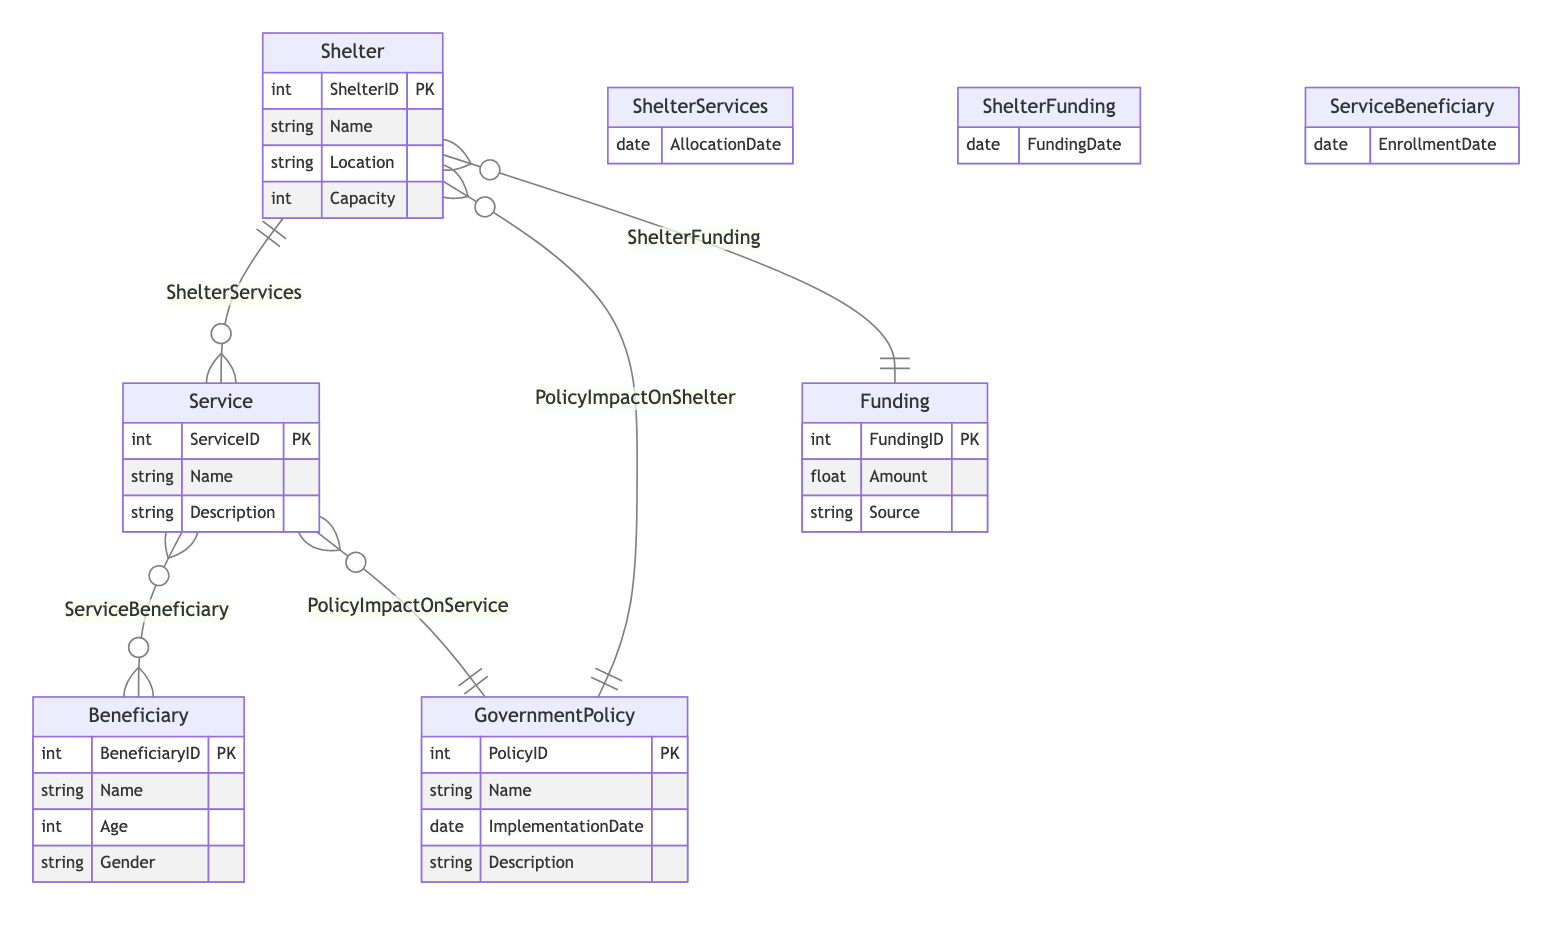What is the primary key attribute for the Shelter entity? The primary key attribute for the Shelter entity is ShelterID, which is designated as PK (Primary Key) in the diagram.
Answer: ShelterID How many entities are present in the diagram? The diagram lists a total of five entities: Shelter, Service, GovernmentPolicy, Funding, and Beneficiary. Thus, the total count is five.
Answer: 5 How many relationships connect the Service entity, and what are they? The Service entity connects with two relationships: ShelterServices (many-to-many with Shelter) and ServiceBeneficiary (many-to-many with Beneficiary). Hence, there are two relationships associated with Service.
Answer: 2 Which entity is impacted by GovernmentPolicy according to the diagram? Both Shelter and Service entities are impacted by GovernmentPolicy, showing that policies influence both entities.
Answer: Shelter and Service What is the maximum capacity of a Shelter? The maximum capacity of a shelter is represented by the Capacity attribute within the Shelter entity structure, indicating the number of individuals it can accommodate.
Answer: Capacity Which relationship requires an AllocationDate attribute? The ShelterServices relationship requires the AllocationDate attribute, which indicates when the services were allocated to the shelter.
Answer: ShelterServices What information must be provided to link Funding to Shelter? Funding must provide FundingDate to link its funding to a specific Shelter in the ShelterFunding relationship.
Answer: FundingDate What is the relationship type between Service and Beneficiary? The relationship type between Service and Beneficiary is many-to-many, as indicated by the notation 'o{' and 'o{', indicating that multiple beneficiaries can access multiple services.
Answer: many-to-many 